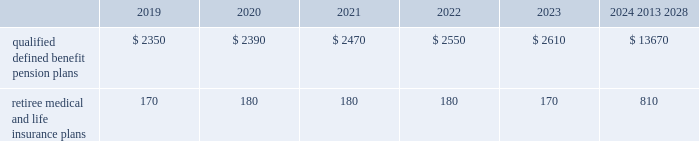Valuation techniques 2013 cash equivalents are mostly comprised of short-term money-market instruments and are valued at cost , which approximates fair value .
U.s .
Equity securities and international equity securities categorized as level 1 are traded on active national and international exchanges and are valued at their closing prices on the last trading day of the year .
For u.s .
Equity securities and international equity securities not traded on an active exchange , or if the closing price is not available , the trustee obtains indicative quotes from a pricing vendor , broker or investment manager .
These securities are categorized as level 2 if the custodian obtains corroborated quotes from a pricing vendor or categorized as level 3 if the custodian obtains uncorroborated quotes from a broker or investment manager .
Commingled equity funds categorized as level 1 are traded on active national and international exchanges and are valued at their closing prices on the last trading day of the year .
For commingled equity funds not traded on an active exchange , or if the closing price is not available , the trustee obtains indicative quotes from a pricing vendor , broker or investment manager .
These securities are categorized as level 2 if the custodian obtains corroborated quotes from a pricing vendor .
Fixed income investments categorized as level 2 are valued by the trustee using pricing models that use verifiable observable market data ( e.g. , interest rates and yield curves observable at commonly quoted intervals and credit spreads ) , bids provided by brokers or dealers or quoted prices of securities with similar characteristics .
Fixed income investments are categorized as level 3 when valuations using observable inputs are unavailable .
The trustee typically obtains pricing based on indicative quotes or bid evaluations from vendors , brokers or the investment manager .
In addition , certain other fixed income investments categorized as level 3 are valued using a discounted cash flow approach .
Significant inputs include projected annuity payments and the discount rate applied to those payments .
Certain commingled equity funds , consisting of equity mutual funds , are valued using the nav .
The nav valuations are based on the underlying investments and typically redeemable within 90 days .
Private equity funds consist of partnership and co-investment funds .
The nav is based on valuation models of the underlying securities , which includes unobservable inputs that cannot be corroborated using verifiable observable market data .
These funds typically have redemption periods between eight and 12 years .
Real estate funds consist of partnerships , most of which are closed-end funds , for which the nav is based on valuation models and periodic appraisals .
These funds typically have redemption periods between eight and 10 years .
Hedge funds consist of direct hedge funds for which the nav is generally based on the valuation of the underlying investments .
Redemptions in hedge funds are based on the specific terms of each fund , and generally range from a minimum of one month to several months .
Contributions and expected benefit payments the funding of our qualified defined benefit pension plans is determined in accordance with erisa , as amended by the ppa , and in a manner consistent with cas and internal revenue code rules .
We made contributions of $ 5.0 billion to our qualified defined benefit pension plans in 2018 , including required and discretionary contributions .
As a result of these contributions , we do not expect to make contributions to our qualified defined benefit pension plans in 2019 .
The table presents estimated future benefit payments , which reflect expected future employee service , as of december 31 , 2018 ( in millions ) : .
Defined contribution plans we maintain a number of defined contribution plans , most with 401 ( k ) features , that cover substantially all of our employees .
Under the provisions of our 401 ( k ) plans , we match most employees 2019 eligible contributions at rates specified in the plan documents .
Our contributions were $ 658 million in 2018 , $ 613 million in 2017 and $ 617 million in 2016 , the majority of which were funded using our common stock .
Our defined contribution plans held approximately 33.3 million and 35.5 million shares of our common stock as of december 31 , 2018 and 2017. .
What is the percentage change in 401 ( k ) contributions from 2016 to 2017? 
Computations: ((613 - 617) / 617)
Answer: -0.00648. Valuation techniques 2013 cash equivalents are mostly comprised of short-term money-market instruments and are valued at cost , which approximates fair value .
U.s .
Equity securities and international equity securities categorized as level 1 are traded on active national and international exchanges and are valued at their closing prices on the last trading day of the year .
For u.s .
Equity securities and international equity securities not traded on an active exchange , or if the closing price is not available , the trustee obtains indicative quotes from a pricing vendor , broker or investment manager .
These securities are categorized as level 2 if the custodian obtains corroborated quotes from a pricing vendor or categorized as level 3 if the custodian obtains uncorroborated quotes from a broker or investment manager .
Commingled equity funds categorized as level 1 are traded on active national and international exchanges and are valued at their closing prices on the last trading day of the year .
For commingled equity funds not traded on an active exchange , or if the closing price is not available , the trustee obtains indicative quotes from a pricing vendor , broker or investment manager .
These securities are categorized as level 2 if the custodian obtains corroborated quotes from a pricing vendor .
Fixed income investments categorized as level 2 are valued by the trustee using pricing models that use verifiable observable market data ( e.g. , interest rates and yield curves observable at commonly quoted intervals and credit spreads ) , bids provided by brokers or dealers or quoted prices of securities with similar characteristics .
Fixed income investments are categorized as level 3 when valuations using observable inputs are unavailable .
The trustee typically obtains pricing based on indicative quotes or bid evaluations from vendors , brokers or the investment manager .
In addition , certain other fixed income investments categorized as level 3 are valued using a discounted cash flow approach .
Significant inputs include projected annuity payments and the discount rate applied to those payments .
Certain commingled equity funds , consisting of equity mutual funds , are valued using the nav .
The nav valuations are based on the underlying investments and typically redeemable within 90 days .
Private equity funds consist of partnership and co-investment funds .
The nav is based on valuation models of the underlying securities , which includes unobservable inputs that cannot be corroborated using verifiable observable market data .
These funds typically have redemption periods between eight and 12 years .
Real estate funds consist of partnerships , most of which are closed-end funds , for which the nav is based on valuation models and periodic appraisals .
These funds typically have redemption periods between eight and 10 years .
Hedge funds consist of direct hedge funds for which the nav is generally based on the valuation of the underlying investments .
Redemptions in hedge funds are based on the specific terms of each fund , and generally range from a minimum of one month to several months .
Contributions and expected benefit payments the funding of our qualified defined benefit pension plans is determined in accordance with erisa , as amended by the ppa , and in a manner consistent with cas and internal revenue code rules .
We made contributions of $ 5.0 billion to our qualified defined benefit pension plans in 2018 , including required and discretionary contributions .
As a result of these contributions , we do not expect to make contributions to our qualified defined benefit pension plans in 2019 .
The table presents estimated future benefit payments , which reflect expected future employee service , as of december 31 , 2018 ( in millions ) : .
Defined contribution plans we maintain a number of defined contribution plans , most with 401 ( k ) features , that cover substantially all of our employees .
Under the provisions of our 401 ( k ) plans , we match most employees 2019 eligible contributions at rates specified in the plan documents .
Our contributions were $ 658 million in 2018 , $ 613 million in 2017 and $ 617 million in 2016 , the majority of which were funded using our common stock .
Our defined contribution plans held approximately 33.3 million and 35.5 million shares of our common stock as of december 31 , 2018 and 2017. .
What is the percentage change in 401 ( k ) contributions from 2017 to 2018? 
Computations: ((658 - 613) / 613)
Answer: 0.07341. 